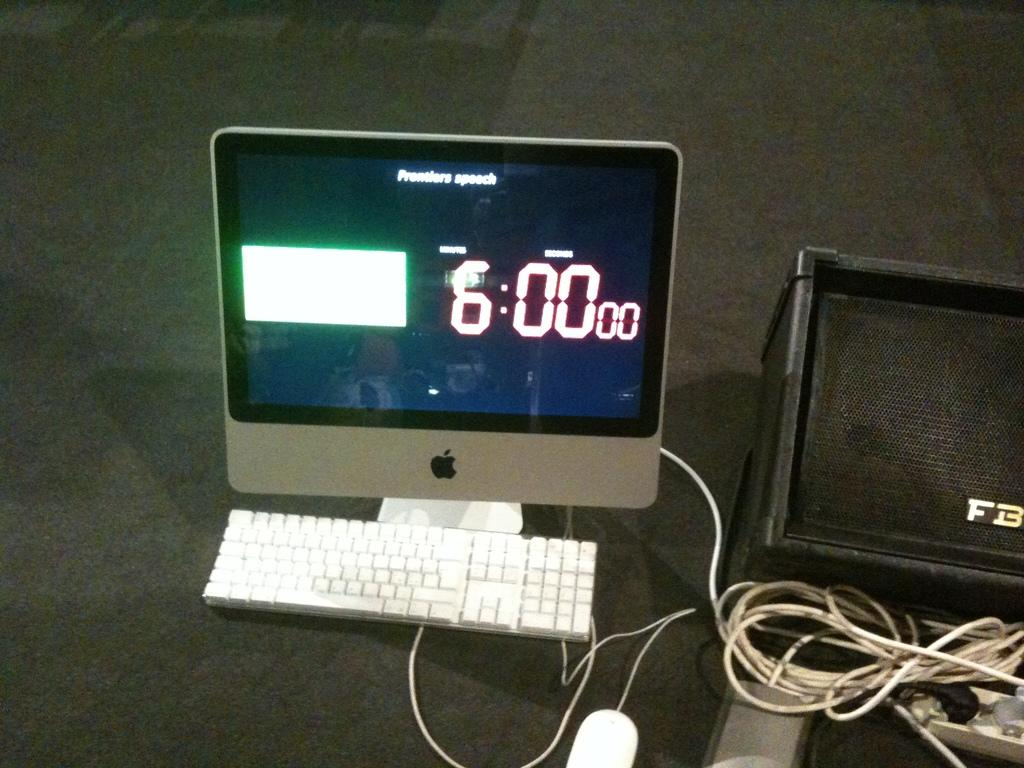Provide a one-sentence caption for the provided image. Monitor that is showing A white square box to the left and 6:00 00 on the right. 